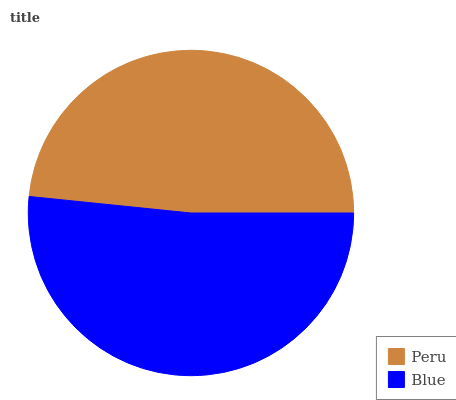Is Peru the minimum?
Answer yes or no. Yes. Is Blue the maximum?
Answer yes or no. Yes. Is Blue the minimum?
Answer yes or no. No. Is Blue greater than Peru?
Answer yes or no. Yes. Is Peru less than Blue?
Answer yes or no. Yes. Is Peru greater than Blue?
Answer yes or no. No. Is Blue less than Peru?
Answer yes or no. No. Is Blue the high median?
Answer yes or no. Yes. Is Peru the low median?
Answer yes or no. Yes. Is Peru the high median?
Answer yes or no. No. Is Blue the low median?
Answer yes or no. No. 